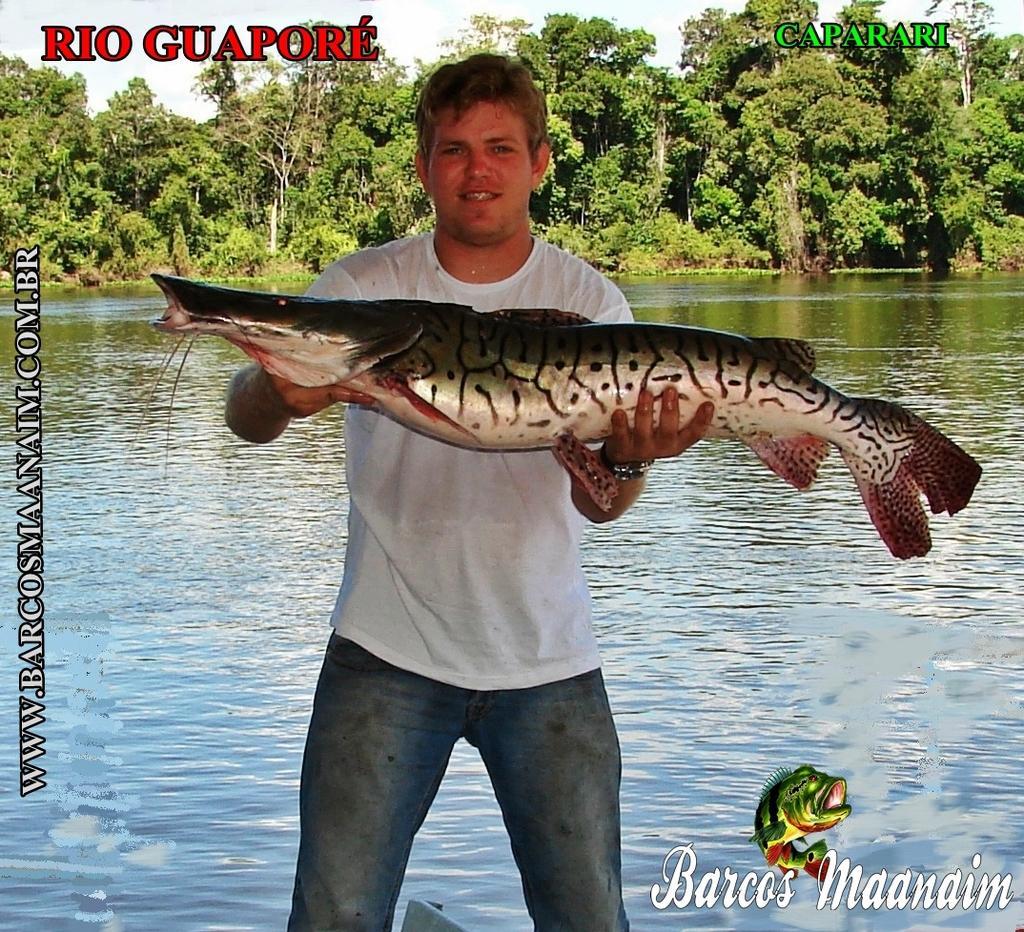How would you summarize this image in a sentence or two? In this image there is a person standing and holding a fish, and at the background there is water , trees,sky and watermarks on the image. 